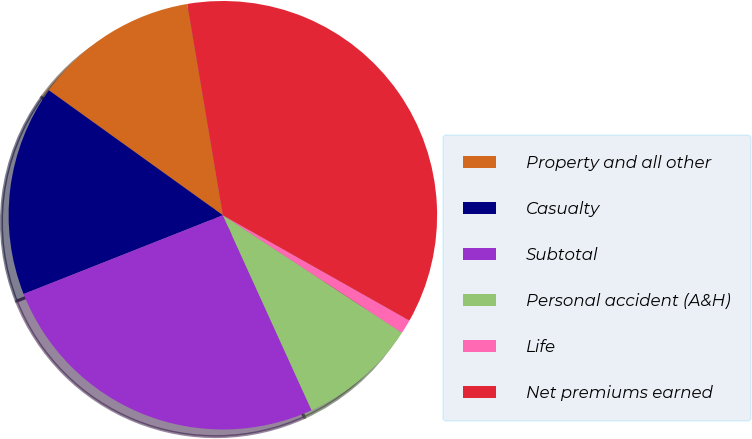Convert chart to OTSL. <chart><loc_0><loc_0><loc_500><loc_500><pie_chart><fcel>Property and all other<fcel>Casualty<fcel>Subtotal<fcel>Personal accident (A&H)<fcel>Life<fcel>Net premiums earned<nl><fcel>12.43%<fcel>15.91%<fcel>25.8%<fcel>8.96%<fcel>1.07%<fcel>35.83%<nl></chart> 